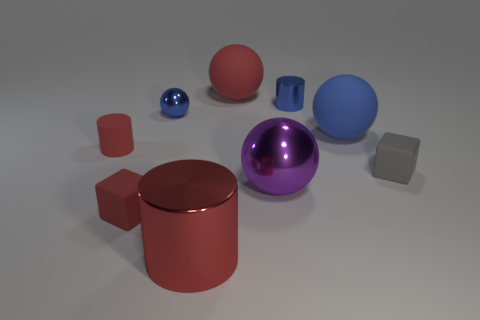Subtract all large spheres. How many spheres are left? 1 Subtract all cylinders. How many objects are left? 6 Subtract 2 cylinders. How many cylinders are left? 1 Subtract all red cylinders. How many cylinders are left? 1 Add 3 tiny purple cylinders. How many tiny purple cylinders exist? 3 Subtract 0 purple cylinders. How many objects are left? 9 Subtract all yellow cylinders. Subtract all cyan spheres. How many cylinders are left? 3 Subtract all green cubes. How many cyan balls are left? 0 Subtract all blue cylinders. Subtract all big metal balls. How many objects are left? 7 Add 5 small red matte cylinders. How many small red matte cylinders are left? 6 